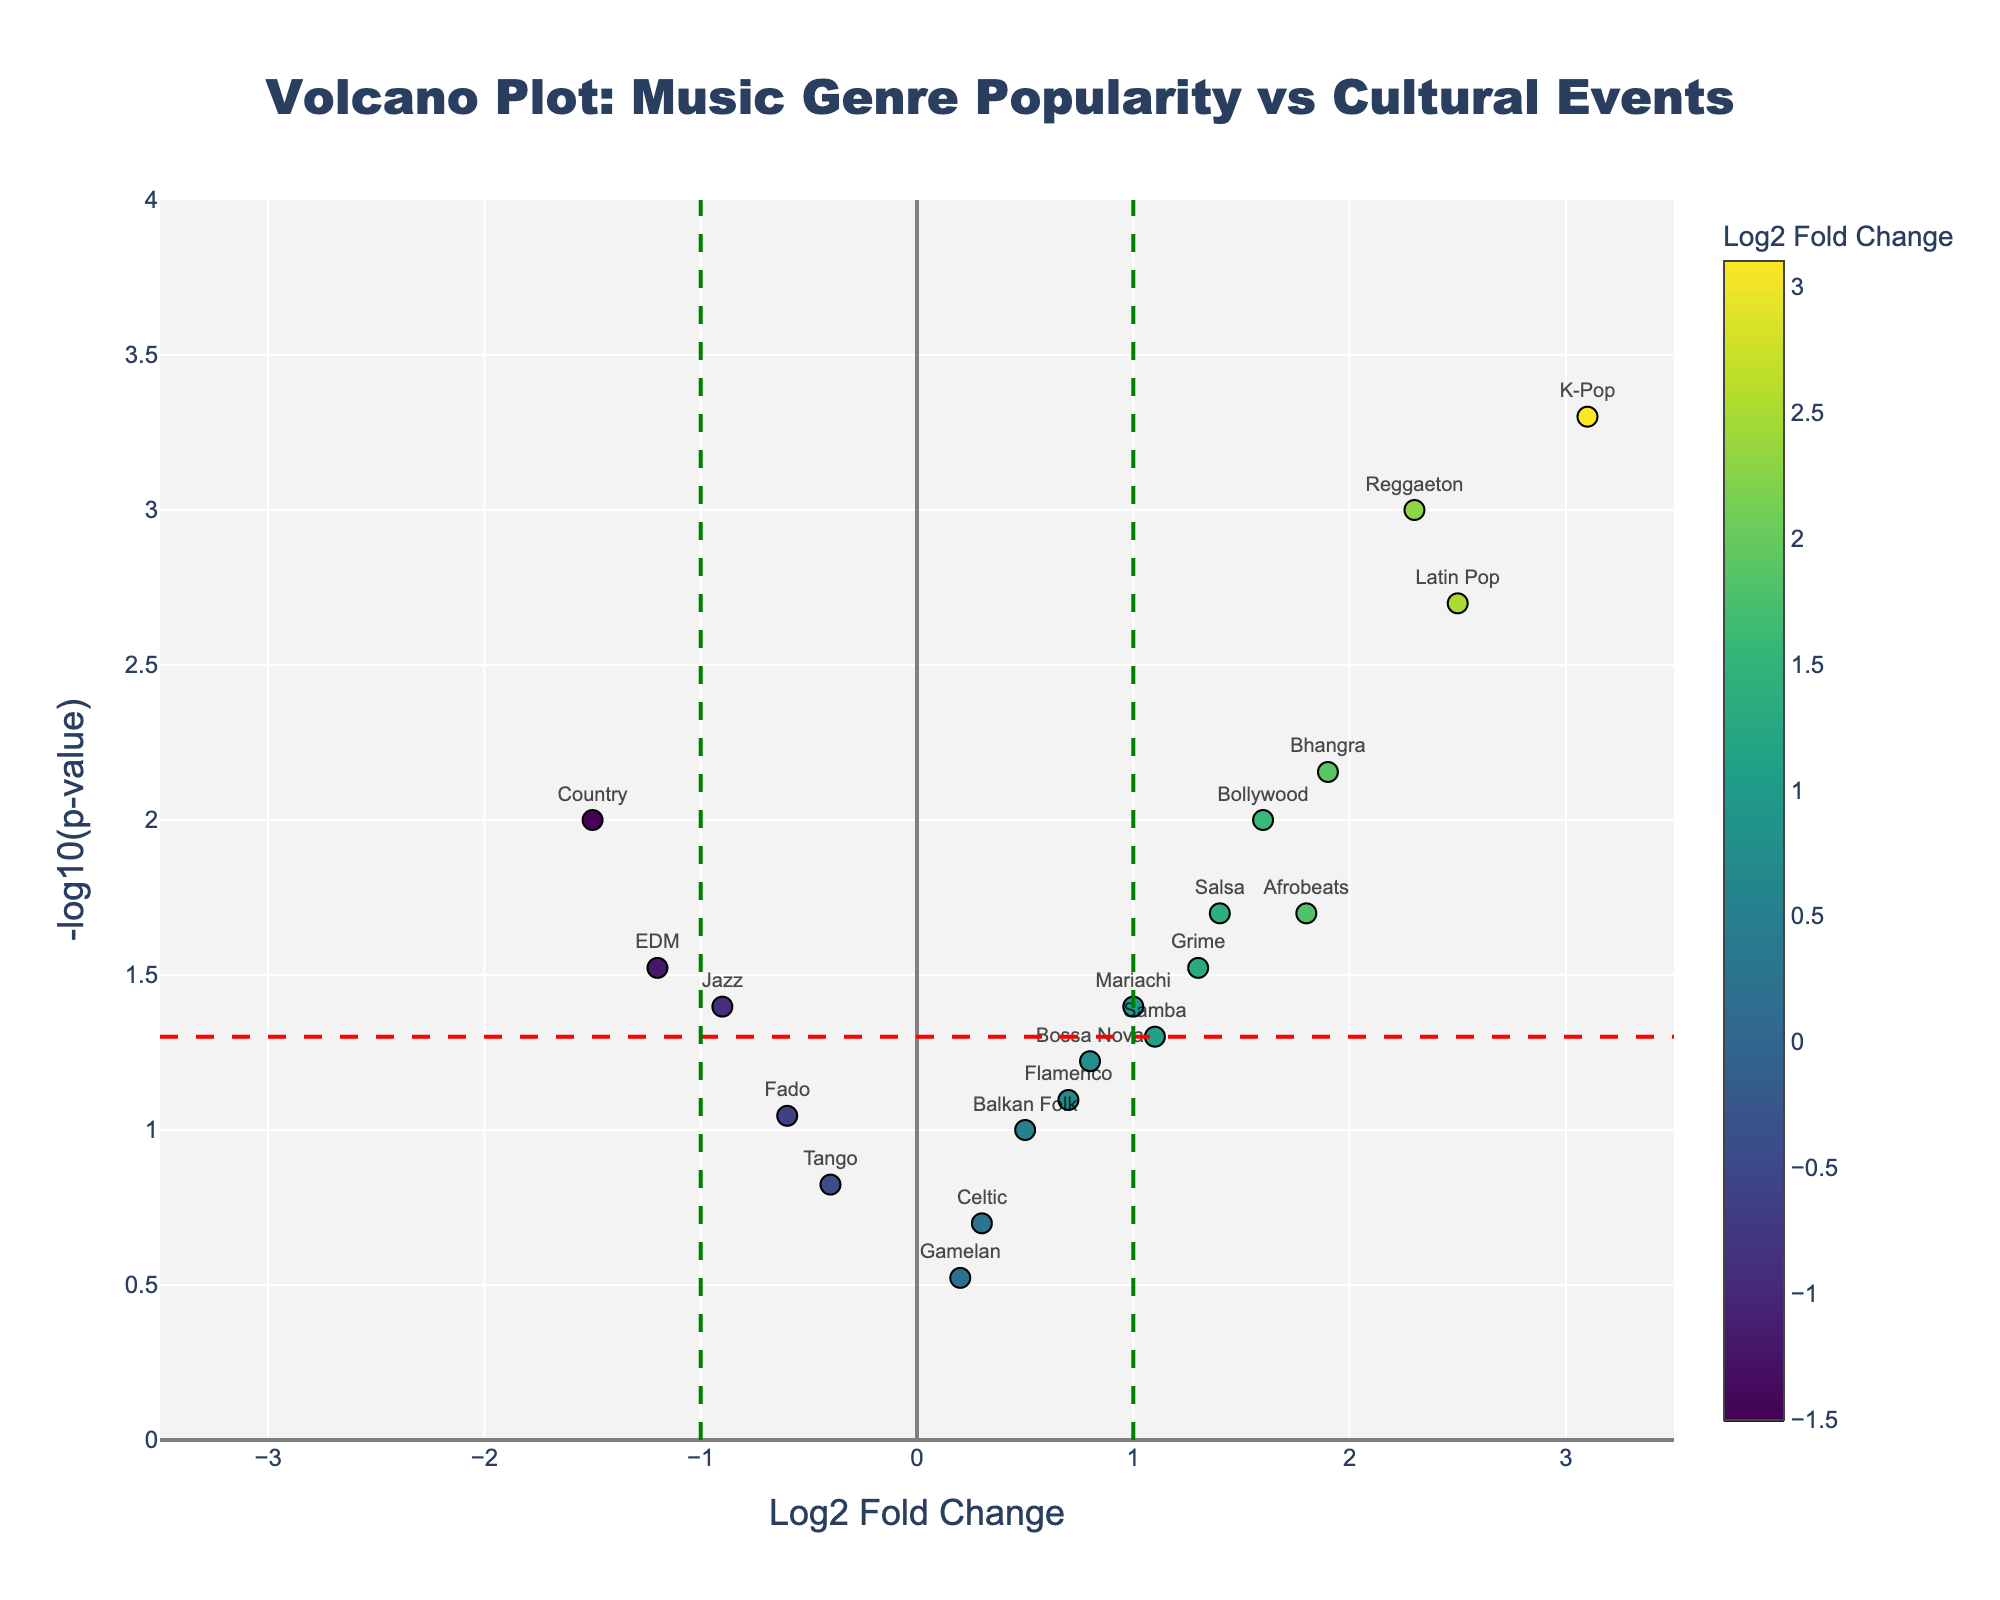What is the title of the plot? The title is located at the top of the plot. It should be easily readable within a text box.
Answer: Volcano Plot: Music Genre Popularity vs Cultural Events Which genre appears to have the highest Log2 Fold Change? The genre with the highest Log2 Fold Change will be at the far right of the x-axis.
Answer: K-Pop What is the p-value threshold line represented by a horizontal dashed red line? The red horizontal dashed line indicates the significance cutoff threshold for p-values, typically at p=0.05, which translates to -log10(0.05).
Answer: -log10(0.05) or approximately 1.301 How many genres have a Log2 Fold Change above 1 and a p-value below 0.05? Count the number of points that lie to the right of x=1 and above the red dashed line.
Answer: Four (Reggaeton, K-Pop, Latin Pop, Bhangra) What is the Log2 Fold Change value for Jazz? The genre names are labeled next to their corresponding points. Find the label for Jazz and check its x-position.
Answer: -0.9 Which genres have Log2 Fold Changes less than -1? Identify the points on the plot that lie to the left of x=-1.
Answer: EDM, Country What is the significance level of the p-value for Afrobeats? The significance level is shown by the y-value of the point representing Afrobeats.
Answer: -log10(p-value), approximately 1.699 How does the Log2 Fold Change for Bossa Nova compare to that of Flamenco? Compare the positions of Bossa Nova and Flamenco along the x-axis.
Answer: Bossa Nova has a higher Log2 Fold Change than Flamenco Which genre has the lowest Log2 Fold Change and what is its corresponding p-value? Find the genre at the far left of the x-axis and match it to its y-value for the p-value.
Answer: Country, p-value = 0.01 What is the Log2 Fold Change threshold line represented by vertical dashed green lines? The green vertical dashed lines indicate typical fold change significance thresholds, usually at Log2 Fold Change = 1 and -1.
Answer: 1 and -1 